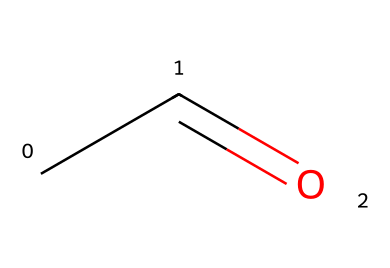What is the molecular formula of the compound represented? The SMILES representation "CC=O" indicates that the compound consists of two carbon atoms (C) and one oxygen atom (O) alongside four hydrogen atoms (H). Thus, the molecular formula is C2H4O.
Answer: C2H4O How many carbon atoms are in acetaldehyde? By analyzing the SMILES "CC=O," we see two carbon atoms are present in the structure, indicated by "CC."
Answer: 2 What type of functional group is present in acetaldehyde? The presence of the carbonyl group indicated by "C=O" in the structure shows that acetaldehyde has an aldehyde functional group.
Answer: aldehyde What is the hybridization of the carbon atoms in acetaldehyde? The carbon atoms in the "CC" part are sp3 hybridized, and the carbon atom in the "C=O" is sp2 hybridized, due to the double bond with oxygen. The reasoning stems from the bonding and geometry observed.
Answer: sp2 and sp3 Which atom in the structure is most electronegative? In the SMILES representation "CC=O," oxygen (O) is the most electronegative atom because it is located in group 16 of the periodic table and has a higher electronegativity compared to carbon and hydrogen.
Answer: oxygen Does acetaldehyde exhibit isomerism? Acetaldehyde can undergo structural isomerism due to its molecular formula C2H4O, as it potentially has other arrangements of atoms; for example, it could exist as vinyl alcohol. This requires understanding of its bonding variations.
Answer: yes 